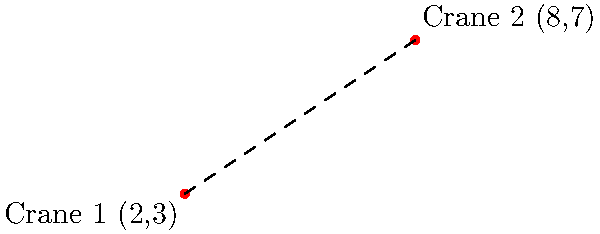On a construction site, two cranes are positioned at different locations. Crane 1 is at coordinates (2,3) and Crane 2 is at coordinates (8,7). What is the distance between these two cranes? To find the distance between two points in a coordinate system, we can use the distance formula, which is derived from the Pythagorean theorem:

$$d = \sqrt{(x_2 - x_1)^2 + (y_2 - y_1)^2}$$

Where $(x_1, y_1)$ are the coordinates of the first point and $(x_2, y_2)$ are the coordinates of the second point.

Let's plug in our values:
$(x_1, y_1) = (2, 3)$ for Crane 1
$(x_2, y_2) = (8, 7)$ for Crane 2

Now, let's calculate:

1) $x_2 - x_1 = 8 - 2 = 6$
2) $y_2 - y_1 = 7 - 3 = 4$
3) $(x_2 - x_1)^2 = 6^2 = 36$
4) $(y_2 - y_1)^2 = 4^2 = 16$
5) $(x_2 - x_1)^2 + (y_2 - y_1)^2 = 36 + 16 = 52$
6) $d = \sqrt{52}$

Simplifying $\sqrt{52}$:
$\sqrt{52} = \sqrt{4 * 13} = 2\sqrt{13}$

Therefore, the distance between the two cranes is $2\sqrt{13}$ units.
Answer: $2\sqrt{13}$ units 